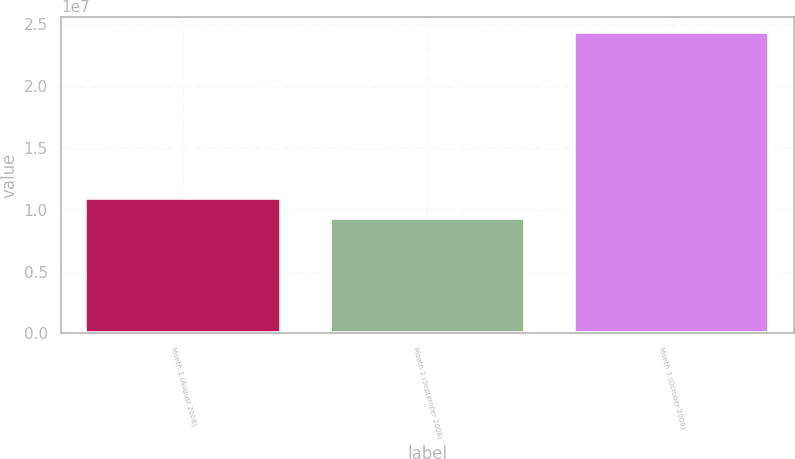Convert chart. <chart><loc_0><loc_0><loc_500><loc_500><bar_chart><fcel>Month 1 (August 2008)<fcel>Month 2 (September 2008)<fcel>Month 3 (October 2008)<nl><fcel>1.09787e+07<fcel>9.32647e+06<fcel>2.43709e+07<nl></chart> 